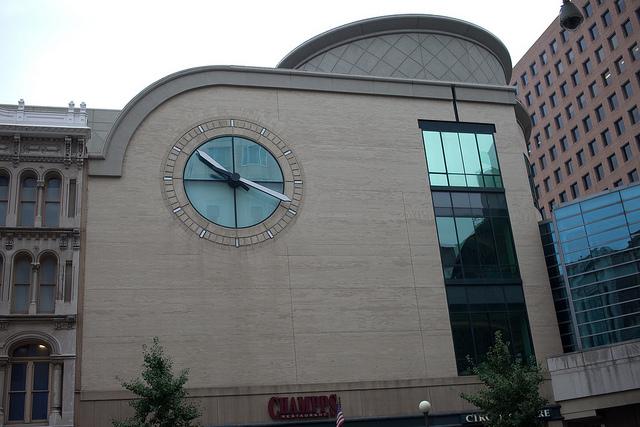What time is on the clock?
Concise answer only. 10:19. What color is the sign on the fence?
Quick response, please. Red. What time is it on the clock shown in the picture?
Write a very short answer. 10:19. Is it 11 o'clock?
Short answer required. No. What time is it?
Answer briefly. 10:20. Is the clock built into the building?
Keep it brief. Yes. 